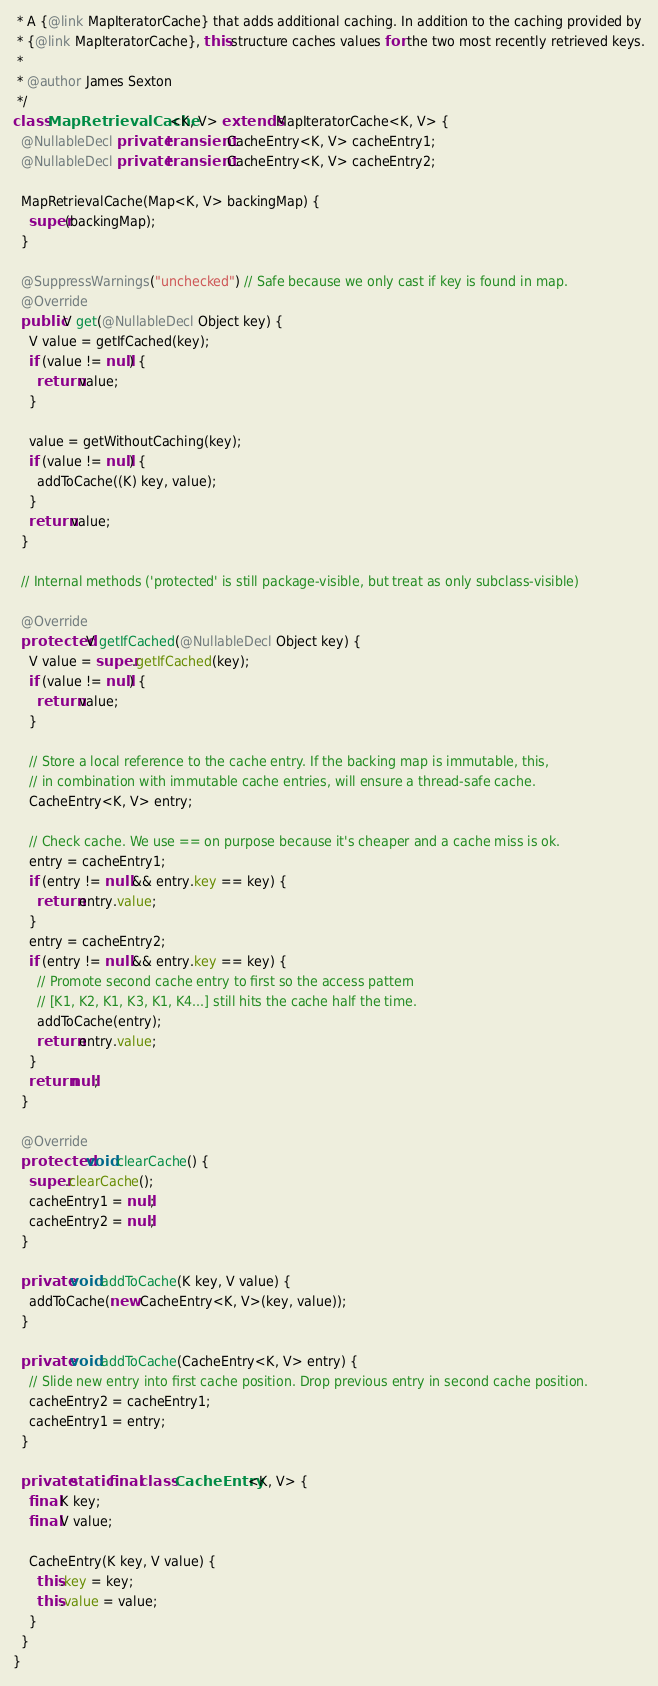Convert code to text. <code><loc_0><loc_0><loc_500><loc_500><_Java_> * A {@link MapIteratorCache} that adds additional caching. In addition to the caching provided by
 * {@link MapIteratorCache}, this structure caches values for the two most recently retrieved keys.
 *
 * @author James Sexton
 */
class MapRetrievalCache<K, V> extends MapIteratorCache<K, V> {
  @NullableDecl private transient CacheEntry<K, V> cacheEntry1;
  @NullableDecl private transient CacheEntry<K, V> cacheEntry2;

  MapRetrievalCache(Map<K, V> backingMap) {
    super(backingMap);
  }

  @SuppressWarnings("unchecked") // Safe because we only cast if key is found in map.
  @Override
  public V get(@NullableDecl Object key) {
    V value = getIfCached(key);
    if (value != null) {
      return value;
    }

    value = getWithoutCaching(key);
    if (value != null) {
      addToCache((K) key, value);
    }
    return value;
  }

  // Internal methods ('protected' is still package-visible, but treat as only subclass-visible)

  @Override
  protected V getIfCached(@NullableDecl Object key) {
    V value = super.getIfCached(key);
    if (value != null) {
      return value;
    }

    // Store a local reference to the cache entry. If the backing map is immutable, this,
    // in combination with immutable cache entries, will ensure a thread-safe cache.
    CacheEntry<K, V> entry;

    // Check cache. We use == on purpose because it's cheaper and a cache miss is ok.
    entry = cacheEntry1;
    if (entry != null && entry.key == key) {
      return entry.value;
    }
    entry = cacheEntry2;
    if (entry != null && entry.key == key) {
      // Promote second cache entry to first so the access pattern
      // [K1, K2, K1, K3, K1, K4...] still hits the cache half the time.
      addToCache(entry);
      return entry.value;
    }
    return null;
  }

  @Override
  protected void clearCache() {
    super.clearCache();
    cacheEntry1 = null;
    cacheEntry2 = null;
  }

  private void addToCache(K key, V value) {
    addToCache(new CacheEntry<K, V>(key, value));
  }

  private void addToCache(CacheEntry<K, V> entry) {
    // Slide new entry into first cache position. Drop previous entry in second cache position.
    cacheEntry2 = cacheEntry1;
    cacheEntry1 = entry;
  }

  private static final class CacheEntry<K, V> {
    final K key;
    final V value;

    CacheEntry(K key, V value) {
      this.key = key;
      this.value = value;
    }
  }
}
</code> 